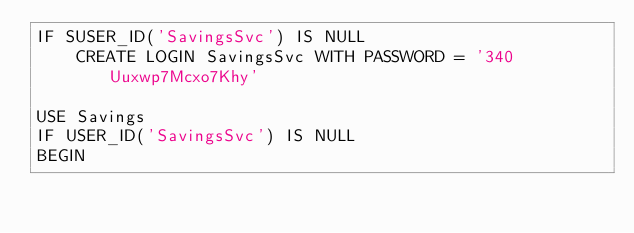<code> <loc_0><loc_0><loc_500><loc_500><_SQL_>IF SUSER_ID('SavingsSvc') IS NULL
    CREATE LOGIN SavingsSvc WITH PASSWORD = '340Uuxwp7Mcxo7Khy'

USE Savings
IF USER_ID('SavingsSvc') IS NULL
BEGIN</code> 